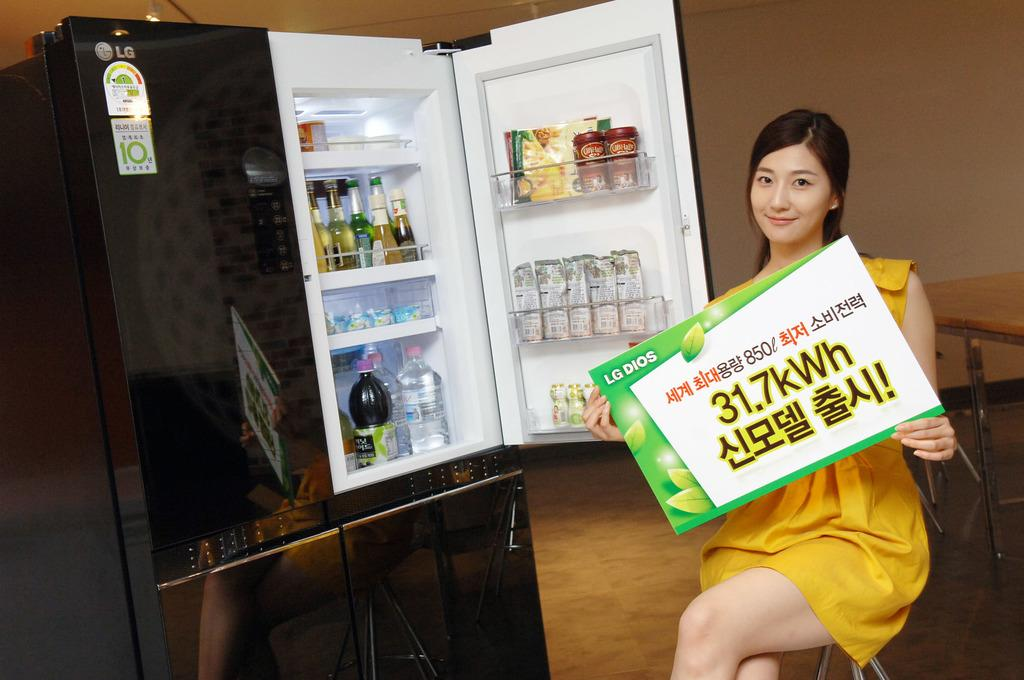Provide a one-sentence caption for the provided image. a woman in front of a mini fridge with a sign saying 31.7kWh. 